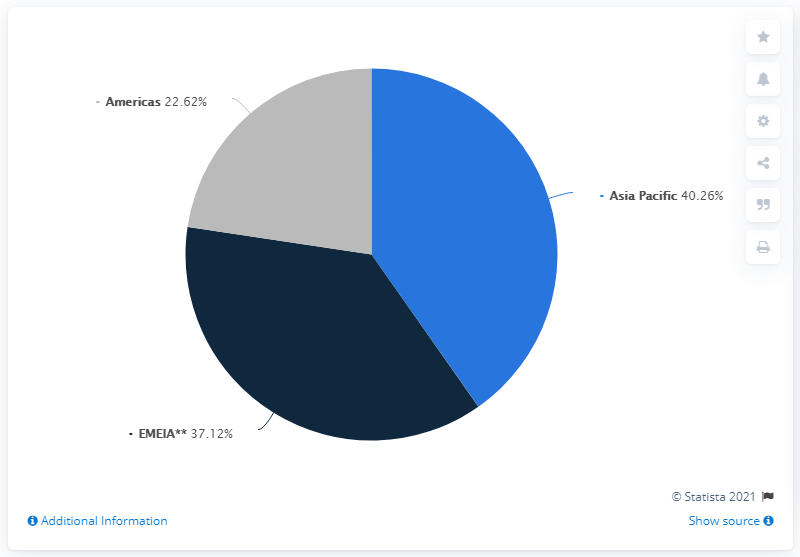Specify some key components in this picture. Burberry generated the most revenue in 2020 from the Asia Pacific region. The sum of revenue from the EMEIA (Europe, Middle East, Africa, and India) and Americas regions is greater than the Asia Pacific region. Burberry generates a significant portion of its revenue from the Asia Pacific region. 